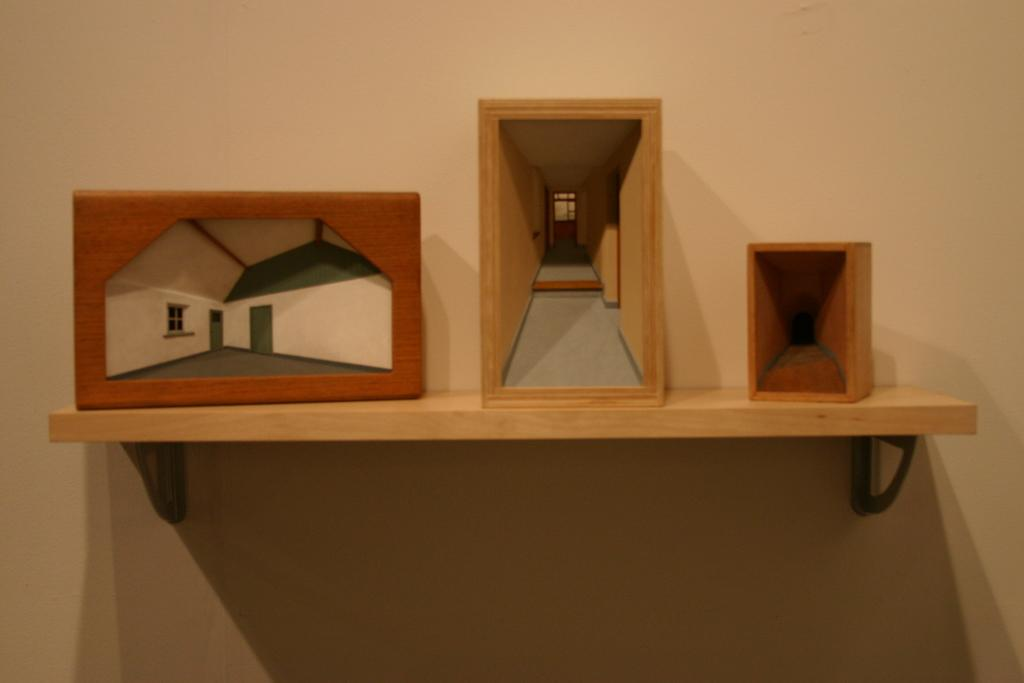What type of objects are placed on the wooden shelf in the image? There are decorations placed on a wooden shelf in the image. Are there any decorations attached to a wall in the image? Yes, there are decorations attached to a wall in the image. What type of fear is depicted in the decorations on the wooden shelf? There is no fear depicted in the decorations on the wooden shelf; they are simply decorative objects. How does the division of the decorations on the wooden shelf reflect the current political climate? There is no indication of any political themes or divisions in the decorations on the wooden shelf. 